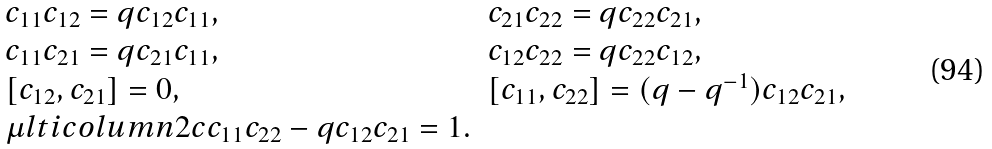Convert formula to latex. <formula><loc_0><loc_0><loc_500><loc_500>\begin{array} { l l } c _ { 1 1 } c _ { 1 2 } = q c _ { 1 2 } c _ { 1 1 } , & c _ { 2 1 } c _ { 2 2 } = q c _ { 2 2 } c _ { 2 1 } , \\ c _ { 1 1 } c _ { 2 1 } = q c _ { 2 1 } c _ { 1 1 } , & c _ { 1 2 } c _ { 2 2 } = q c _ { 2 2 } c _ { 1 2 } , \\ \left [ c _ { 1 2 } , c _ { 2 1 } \right ] = 0 , & \left [ c _ { 1 1 } , c _ { 2 2 } \right ] = ( q - q ^ { - 1 } ) c _ { 1 2 } c _ { 2 1 } , \\ \mu l t i c o l u m n { 2 } { c } { c _ { 1 1 } c _ { 2 2 } - q c _ { 1 2 } c _ { 2 1 } = 1 . } \end{array}</formula> 